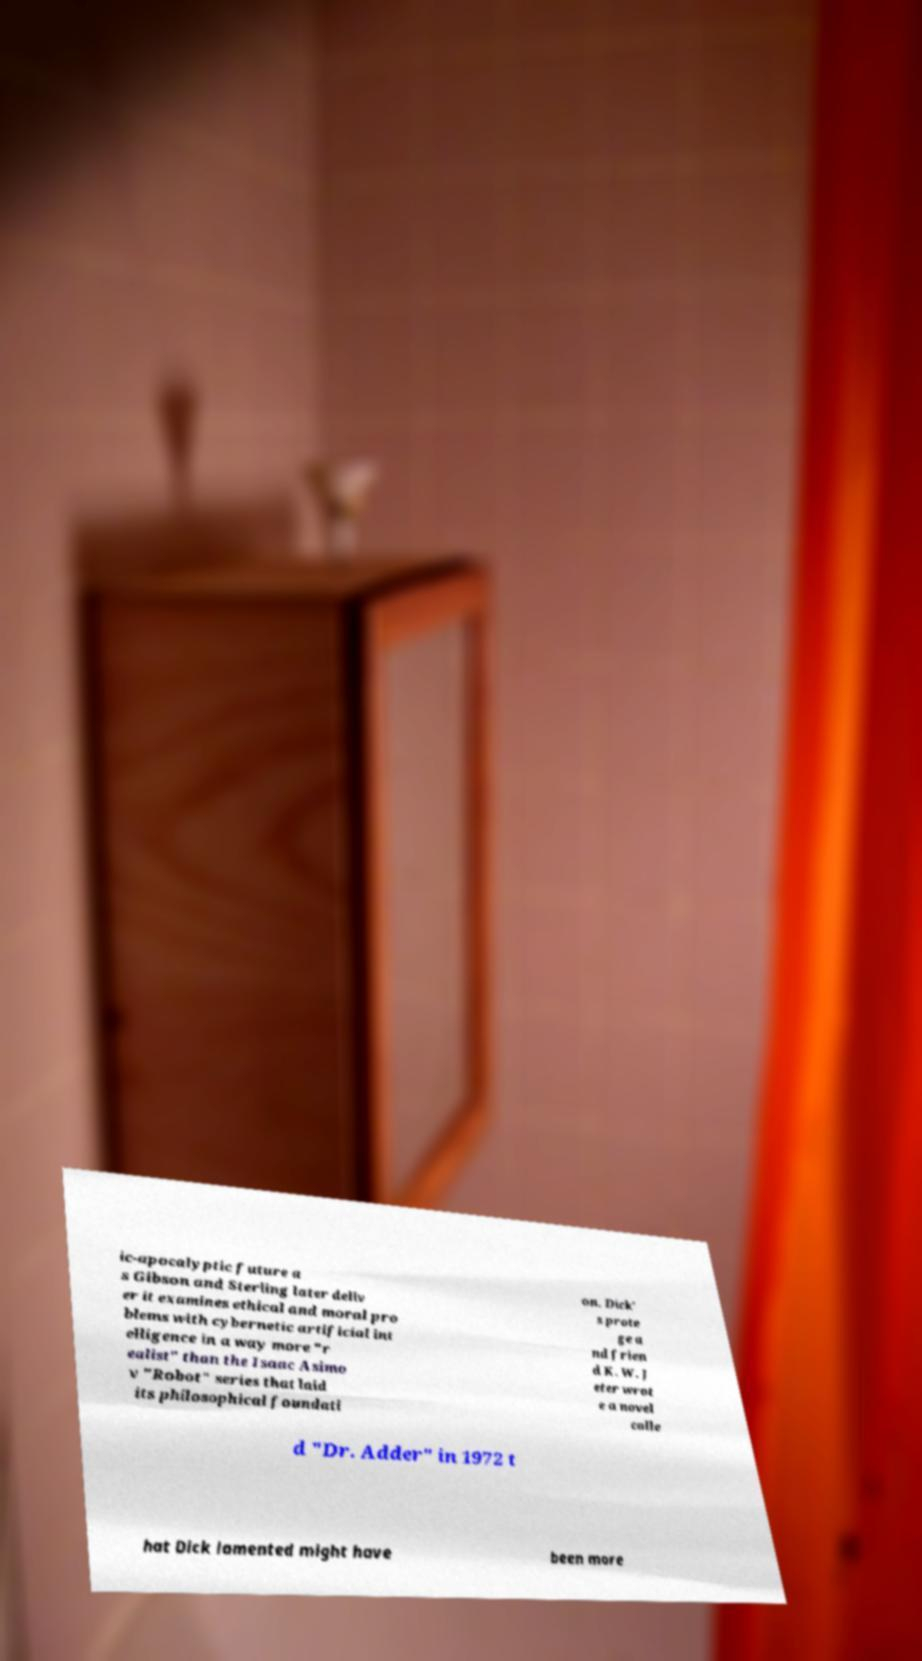Could you extract and type out the text from this image? ic-apocalyptic future a s Gibson and Sterling later deliv er it examines ethical and moral pro blems with cybernetic artificial int elligence in a way more "r ealist" than the Isaac Asimo v "Robot" series that laid its philosophical foundati on. Dick' s prote ge a nd frien d K. W. J eter wrot e a novel calle d "Dr. Adder" in 1972 t hat Dick lamented might have been more 